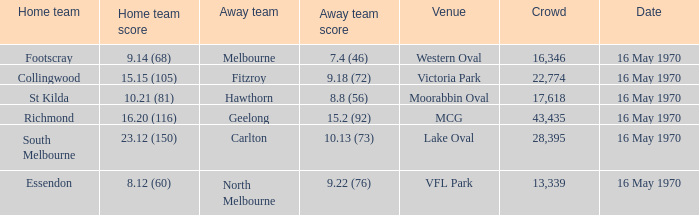Which guest team scored a total of 9.18 (72)? Fitzroy. Could you parse the entire table? {'header': ['Home team', 'Home team score', 'Away team', 'Away team score', 'Venue', 'Crowd', 'Date'], 'rows': [['Footscray', '9.14 (68)', 'Melbourne', '7.4 (46)', 'Western Oval', '16,346', '16 May 1970'], ['Collingwood', '15.15 (105)', 'Fitzroy', '9.18 (72)', 'Victoria Park', '22,774', '16 May 1970'], ['St Kilda', '10.21 (81)', 'Hawthorn', '8.8 (56)', 'Moorabbin Oval', '17,618', '16 May 1970'], ['Richmond', '16.20 (116)', 'Geelong', '15.2 (92)', 'MCG', '43,435', '16 May 1970'], ['South Melbourne', '23.12 (150)', 'Carlton', '10.13 (73)', 'Lake Oval', '28,395', '16 May 1970'], ['Essendon', '8.12 (60)', 'North Melbourne', '9.22 (76)', 'VFL Park', '13,339', '16 May 1970']]} 